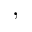Convert formula to latex. <formula><loc_0><loc_0><loc_500><loc_500>,</formula> 